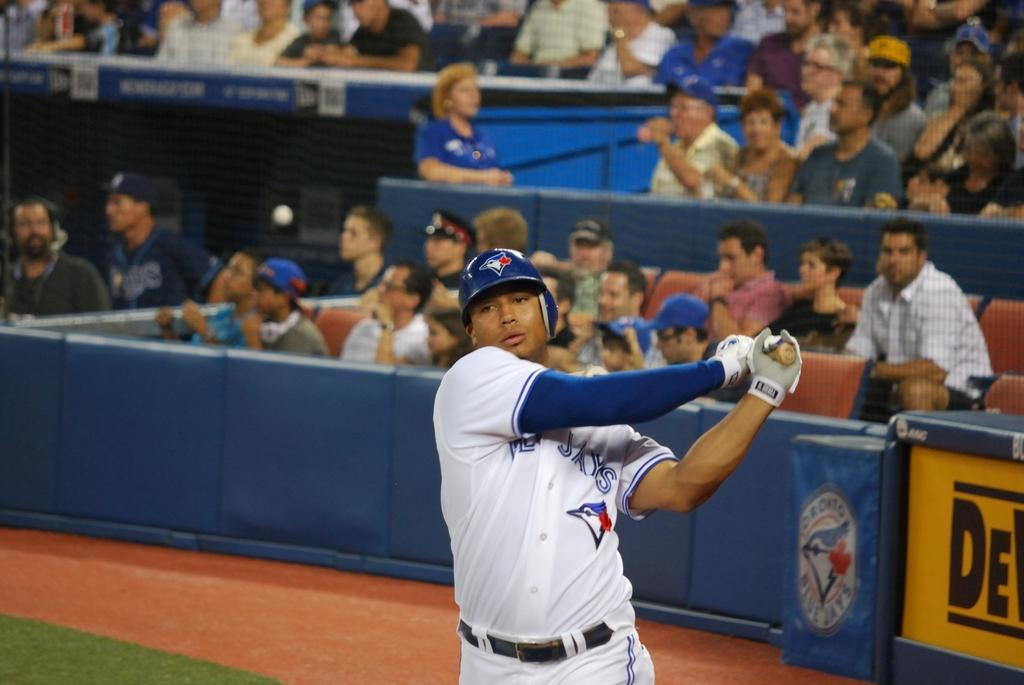<image>
Summarize the visual content of the image. a baseball player swings his bat in front of a bluejays banner 